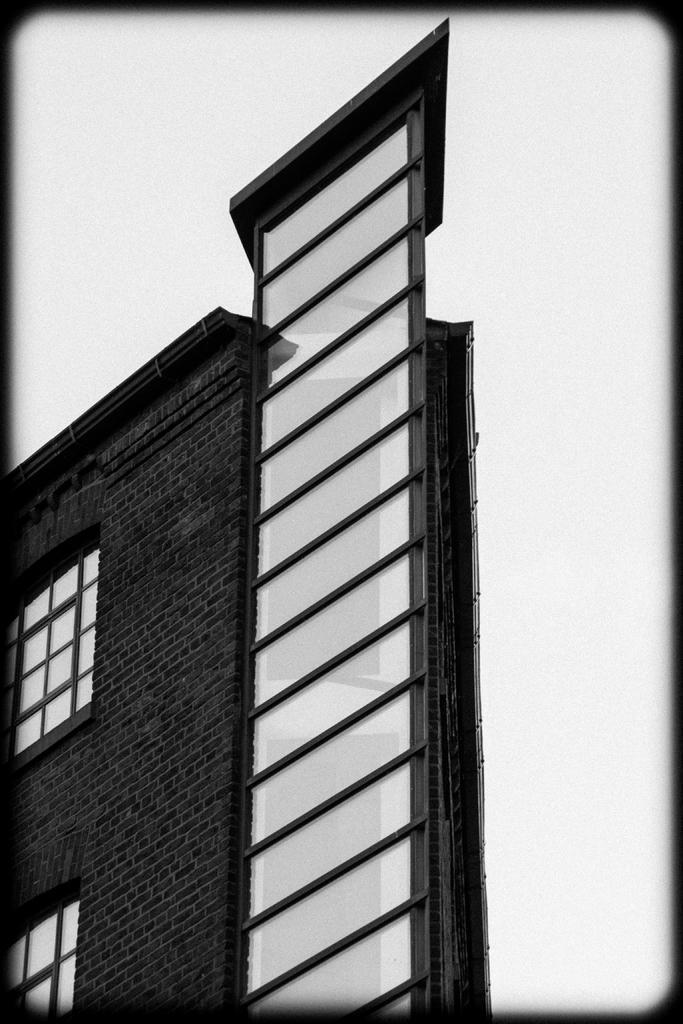Could you give a brief overview of what you see in this image? In this picture we can see a building with windows and in the background we can see white color. 